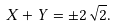<formula> <loc_0><loc_0><loc_500><loc_500>X + Y = \pm 2 \sqrt { 2 } .</formula> 